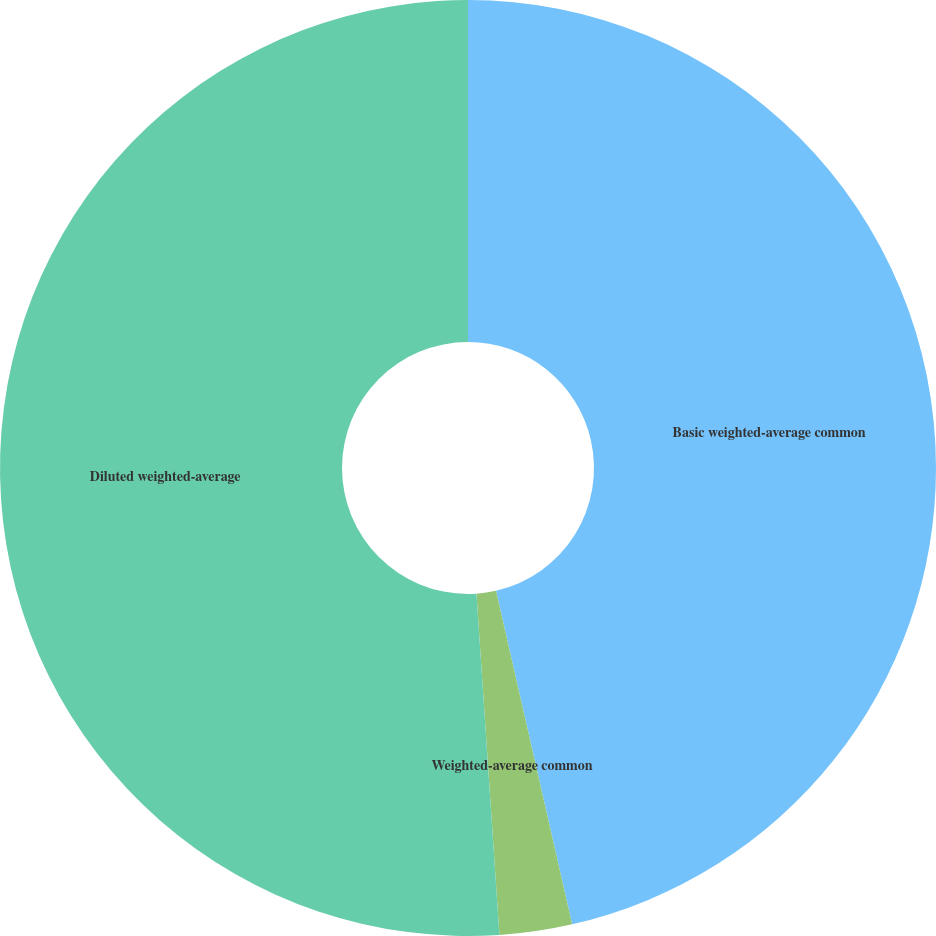<chart> <loc_0><loc_0><loc_500><loc_500><pie_chart><fcel>Basic weighted-average common<fcel>Weighted-average common<fcel>Diluted weighted-average<nl><fcel>46.43%<fcel>2.5%<fcel>51.07%<nl></chart> 